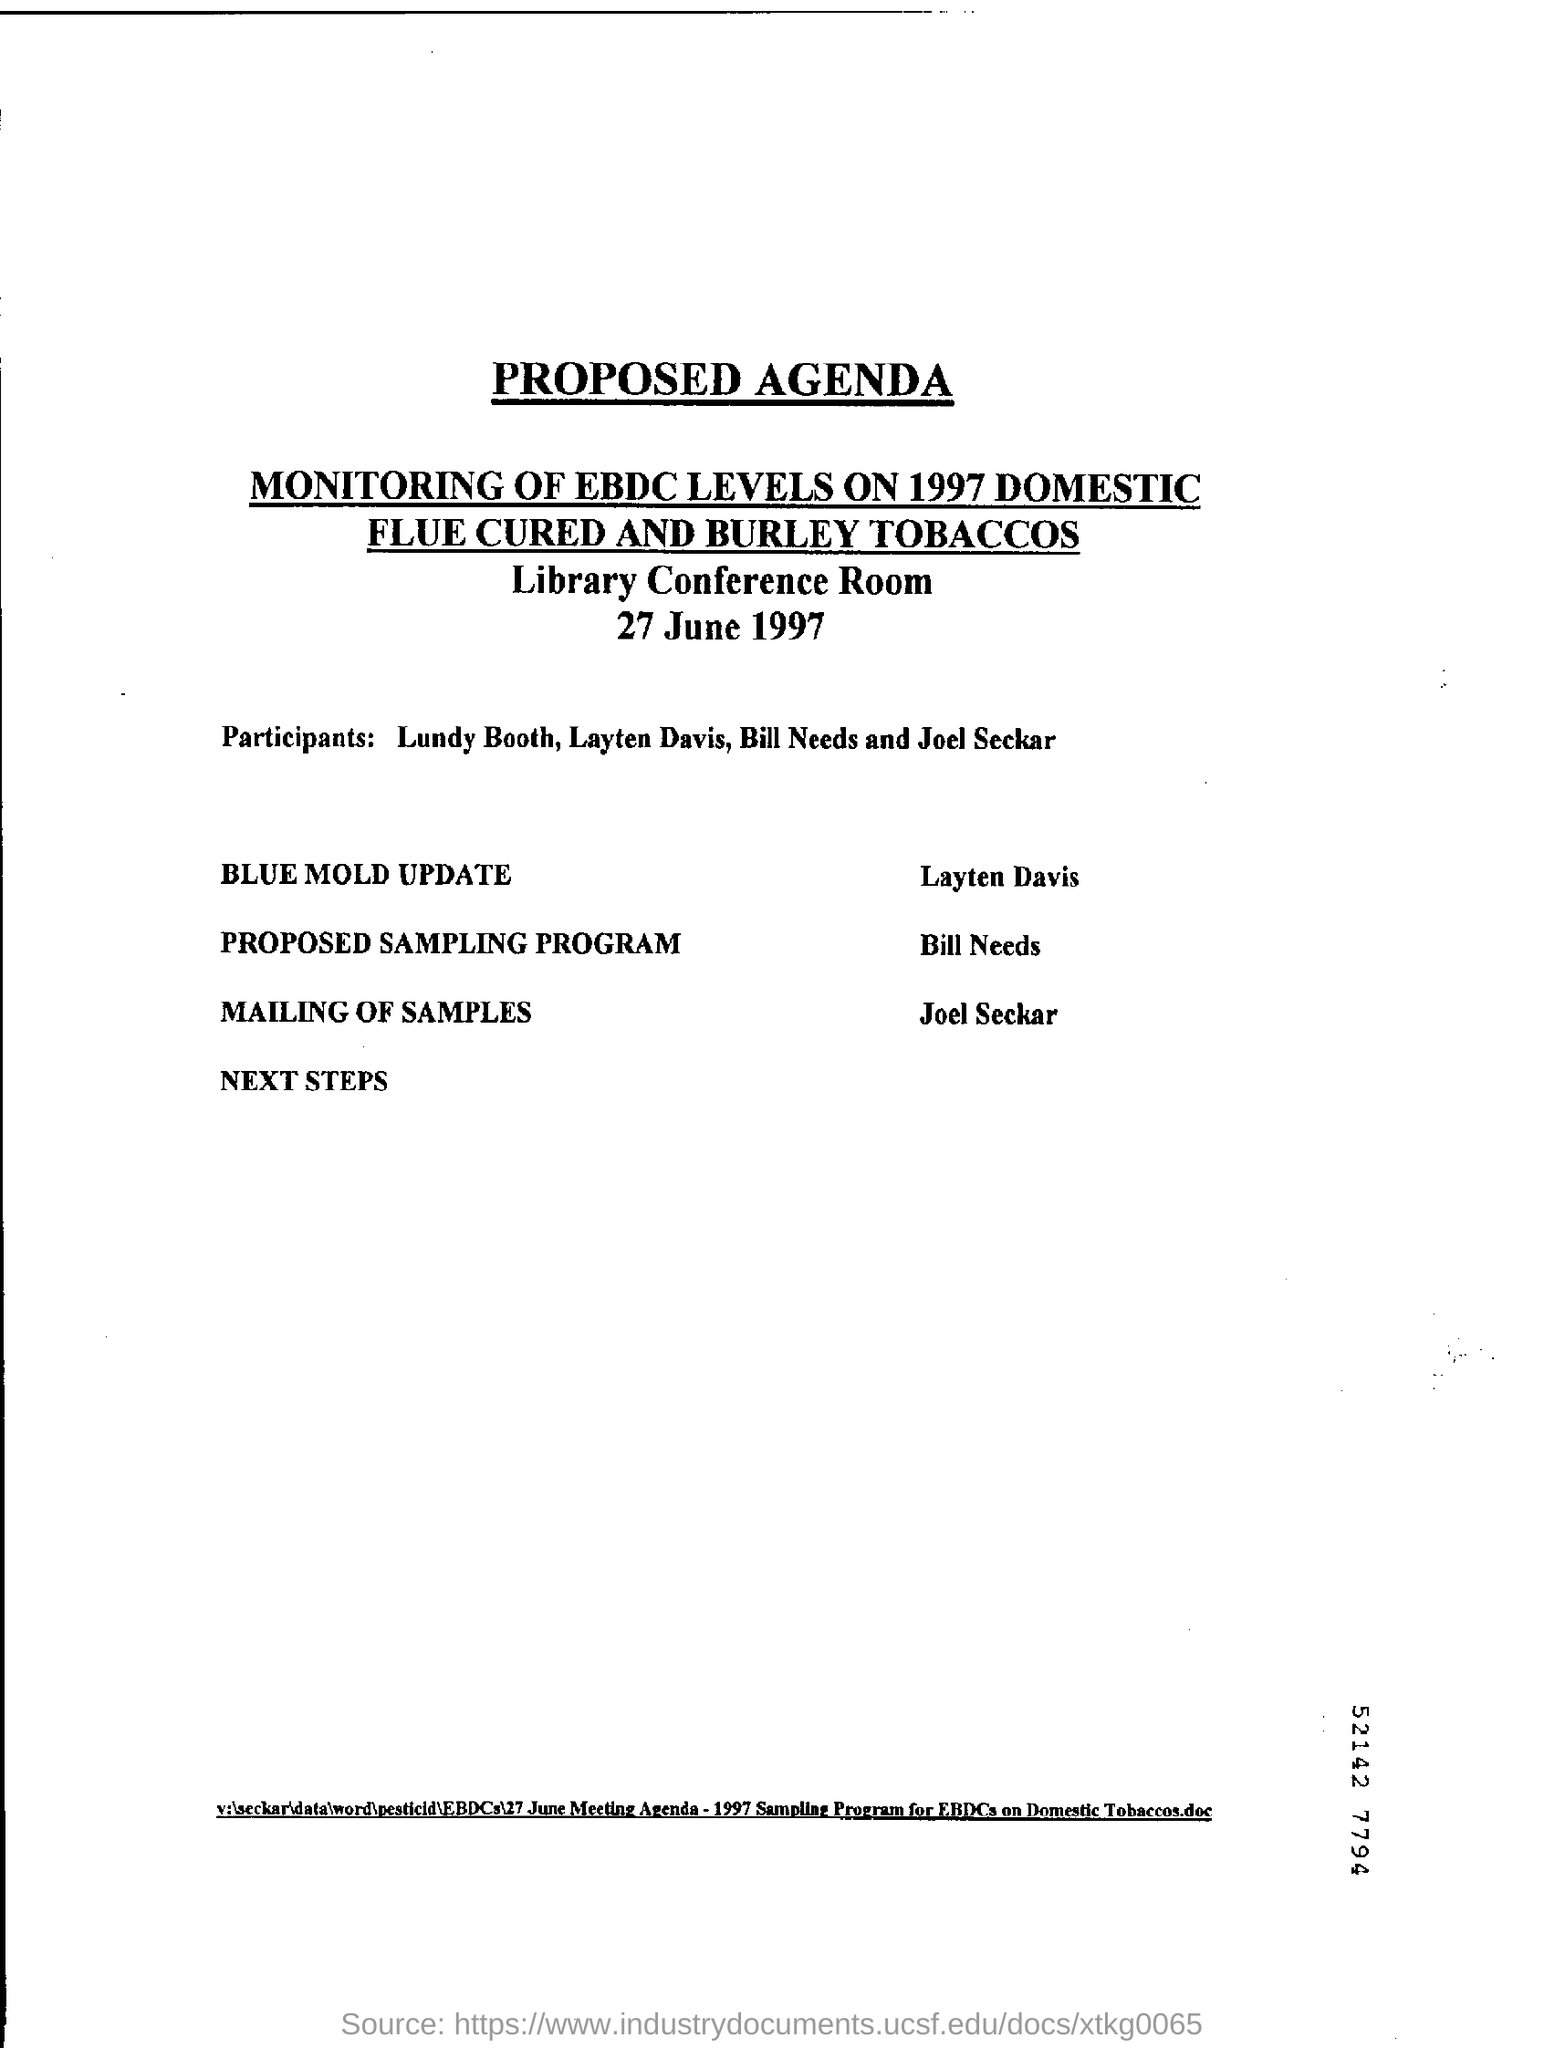Identify some key points in this picture. The program will be held on June 27, 1997. Layten Davis will be responsible for completing the BLUE MOLD UPDATE. Flue-cured and burley tobaccos are the two types of tobacco mentioned. 